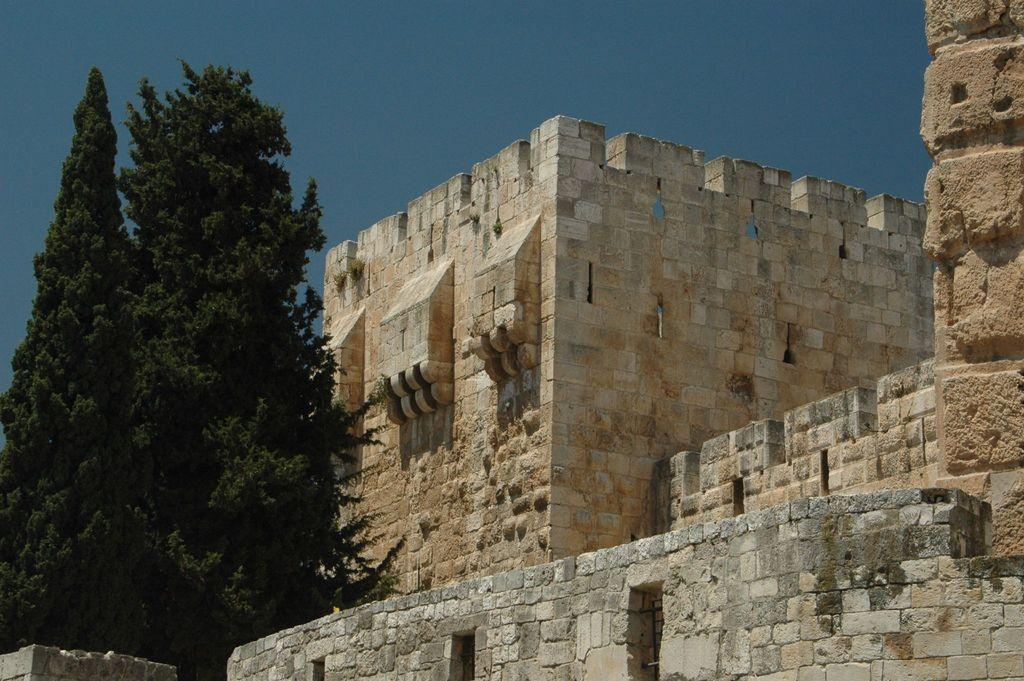What type of structure is present in the image? There is a fort in the image. What other natural elements can be seen in the image? There are trees in the image. What is visible in the background of the image? The sky is visible in the background of the image. What is the color of the sky in the image? The color of the sky is blue. What type of needle is being used to sew the fort in the image? There is no needle present in the image, and the fort is not being sewn. 